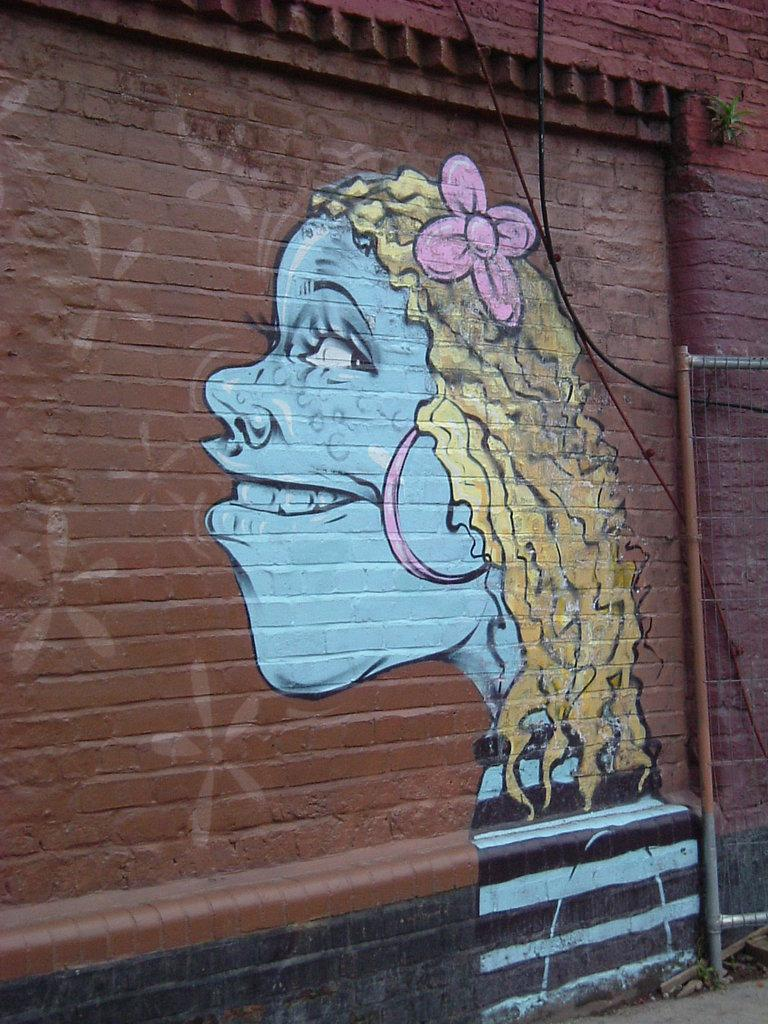What is depicted in the graffiti in the image? The graffiti depicts a girl. Where is the graffiti located? The graffiti is on a wall. Can you describe the style or medium of the graffiti? The provided facts do not mention the style or medium of the graffiti. What type of quince is being used to create the graffiti in the image? There is no mention of quince being used to create the graffiti in the image. The graffiti is likely created using paint or other materials, not fruit. 